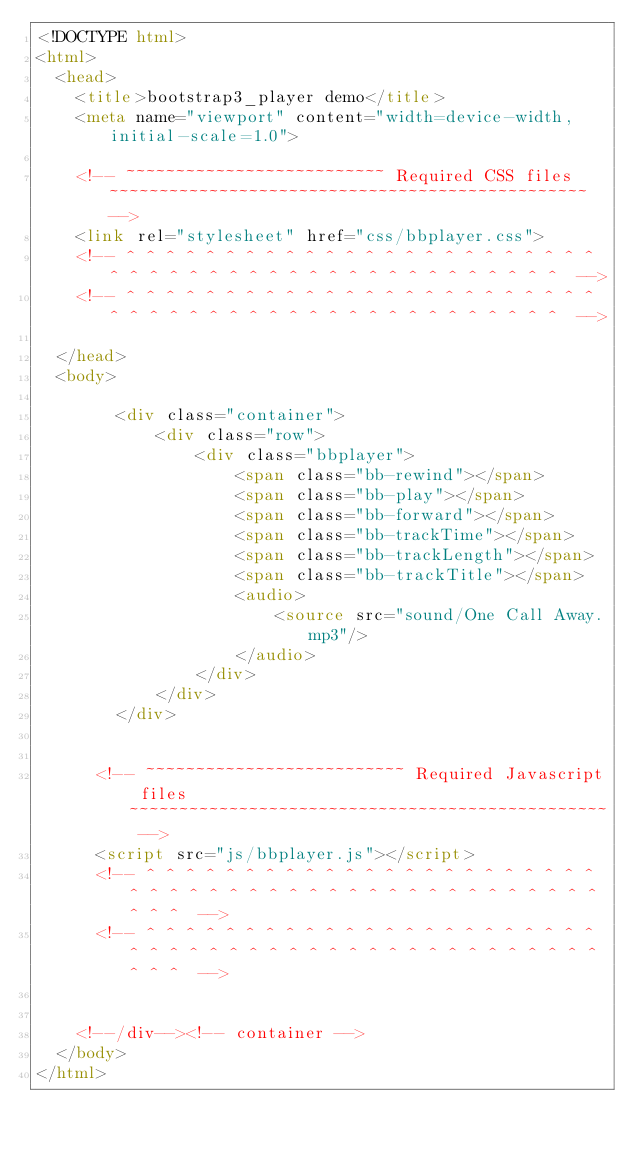Convert code to text. <code><loc_0><loc_0><loc_500><loc_500><_HTML_><!DOCTYPE html>
<html>
  <head>
    <title>bootstrap3_player demo</title>
    <meta name="viewport" content="width=device-width, initial-scale=1.0">

    <!-- ~~~~~~~~~~~~~~~~~~~~~~~~~~ Required CSS files ~~~~~~~~~~~~~~~~~~~~~~~~~~~~~~~~~~~~~~~~~~~~~~~~ -->
    <link rel="stylesheet" href="css/bbplayer.css">
    <!-- ^ ^ ^ ^ ^ ^ ^ ^ ^ ^ ^ ^ ^ ^ ^ ^ ^ ^ ^ ^ ^ ^ ^ ^ ^ ^ ^ ^ ^ ^ ^ ^ ^ ^ ^ ^ ^ ^ ^ ^ ^ ^ ^ ^ ^ ^ ^  -->
    <!-- ^ ^ ^ ^ ^ ^ ^ ^ ^ ^ ^ ^ ^ ^ ^ ^ ^ ^ ^ ^ ^ ^ ^ ^ ^ ^ ^ ^ ^ ^ ^ ^ ^ ^ ^ ^ ^ ^ ^ ^ ^ ^ ^ ^ ^ ^ ^  -->

  </head>
  <body>
		    
		<div class="container">
			<div class="row">
				<div class="bbplayer">
					<span class="bb-rewind"></span>
					<span class="bb-play"></span>
					<span class="bb-forward"></span>
					<span class="bb-trackTime"></span>
				  	<span class="bb-trackLength"></span>
				  	<span class="bb-trackTitle"></span>
				  	<audio>
				    	<source src="sound/One Call Away.mp3"/>
				  	</audio>
				</div>
			</div>
		</div> 
      

      <!-- ~~~~~~~~~~~~~~~~~~~~~~~~~~ Required Javascript files ~~~~~~~~~~~~~~~~~~~~~~~~~~~~~~~~~~~~~~~~~~~~~~~~ -->
      <script src="js/bbplayer.js"></script>
      <!-- ^ ^ ^ ^ ^ ^ ^ ^ ^ ^ ^ ^ ^ ^ ^ ^ ^ ^ ^ ^ ^ ^ ^ ^ ^ ^ ^ ^ ^ ^ ^ ^ ^ ^ ^ ^ ^ ^ ^ ^ ^ ^ ^ ^ ^ ^ ^ ^ ^ ^  -->
      <!-- ^ ^ ^ ^ ^ ^ ^ ^ ^ ^ ^ ^ ^ ^ ^ ^ ^ ^ ^ ^ ^ ^ ^ ^ ^ ^ ^ ^ ^ ^ ^ ^ ^ ^ ^ ^ ^ ^ ^ ^ ^ ^ ^ ^ ^ ^ ^ ^ ^ ^  -->


    <!--/div--><!-- container -->
  </body>
</html>
</code> 